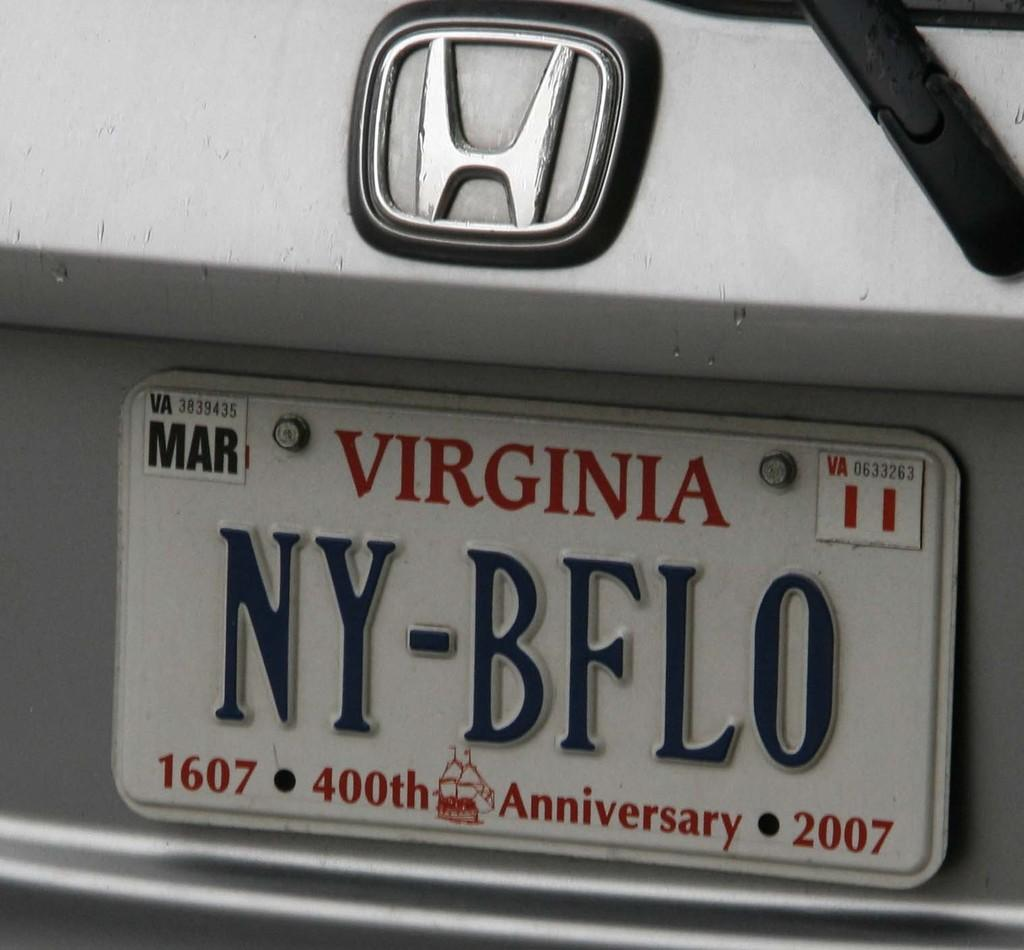What is displayed on the vehicle in the image? There is a logo on a vehicle in the image. What else can be seen on the vehicle? There is a number plate on the vehicle in the image. How many zebras are present in the image? There are no zebras present in the image. What type of secretary is depicted in the image? There is no secretary depicted in the image. 